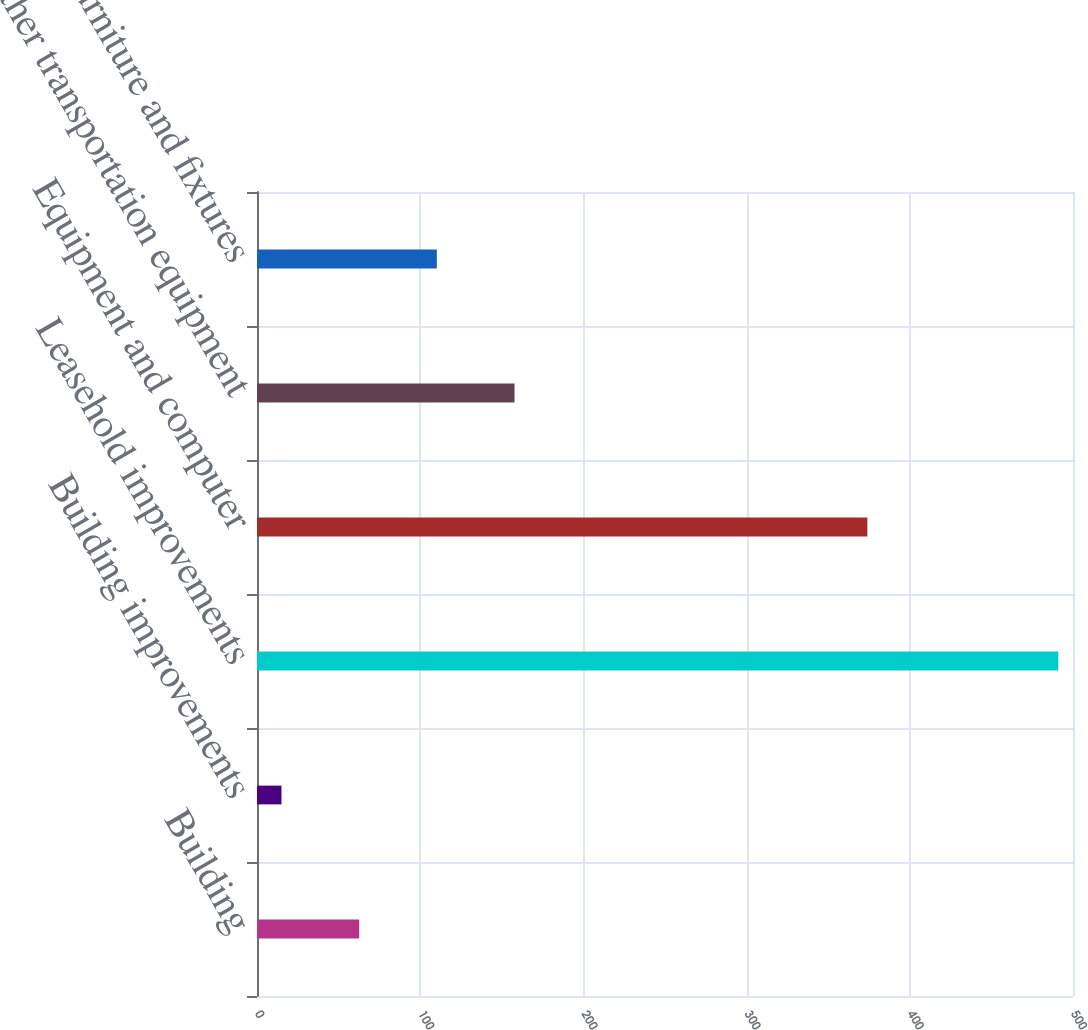Convert chart to OTSL. <chart><loc_0><loc_0><loc_500><loc_500><bar_chart><fcel>Building<fcel>Building improvements<fcel>Leasehold improvements<fcel>Equipment and computer<fcel>Other transportation equipment<fcel>Furniture and fixtures<nl><fcel>62.6<fcel>15<fcel>491<fcel>374<fcel>157.8<fcel>110.2<nl></chart> 